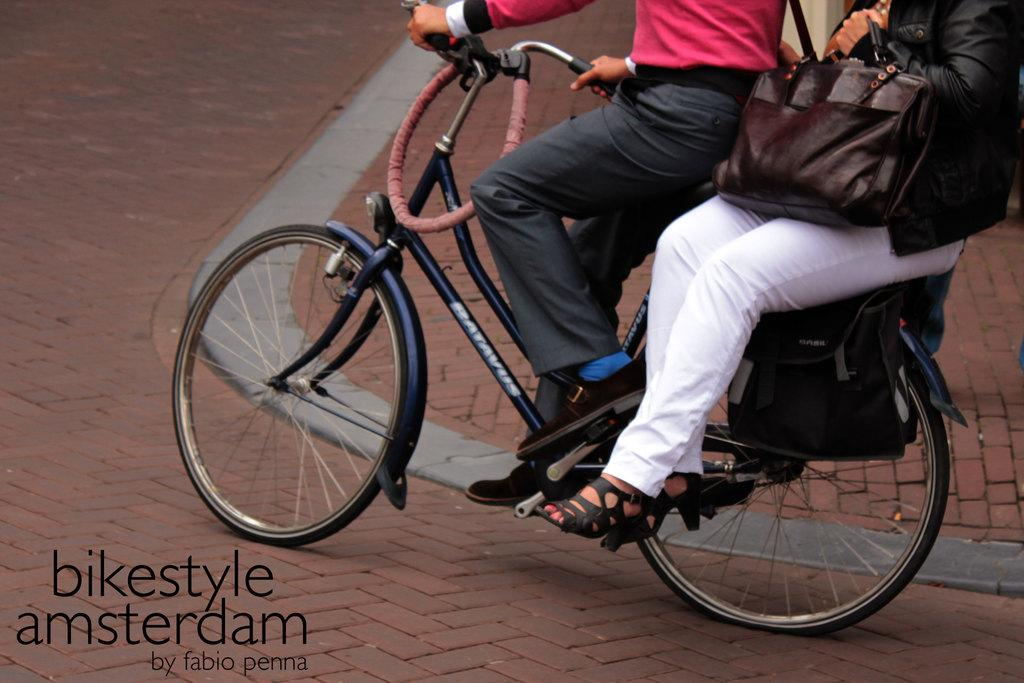What is the main subject of the image? The main subject of the image is a person riding a bicycle. Can you describe the position of the person on the bicycle? There is a person sitting on the bicycle. Is there any text present in the image? Yes, there is some text written on the image. How does the person adjust the fire on the bicycle in the image? There is no fire present on the bicycle in the image. What type of mitten is the person wearing while riding the bicycle? The image does not show the person wearing any mittens. 